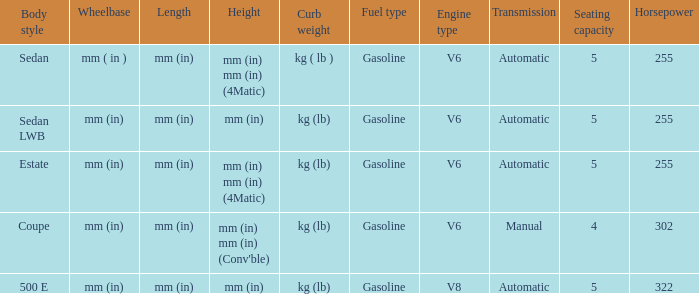Could you help me parse every detail presented in this table? {'header': ['Body style', 'Wheelbase', 'Length', 'Height', 'Curb weight', 'Fuel type', 'Engine type', 'Transmission', 'Seating capacity', 'Horsepower'], 'rows': [['Sedan', 'mm ( in )', 'mm (in)', 'mm (in) mm (in) (4Matic)', 'kg ( lb )', 'Gasoline', 'V6', 'Automatic', '5', '255'], ['Sedan LWB', 'mm (in)', 'mm (in)', 'mm (in)', 'kg (lb)', 'Gasoline', 'V6', 'Automatic', '5', '255'], ['Estate', 'mm (in)', 'mm (in)', 'mm (in) mm (in) (4Matic)', 'kg (lb)', 'Gasoline', 'V6', 'Automatic', '5', '255'], ['Coupe', 'mm (in)', 'mm (in)', "mm (in) mm (in) (Conv'ble)", 'kg (lb)', 'Gasoline', 'V6', 'Manual', '4', '302'], ['500 E', 'mm (in)', 'mm (in)', 'mm (in)', 'kg (lb)', 'Gasoline', 'V8', 'Automatic', '5', '322']]} What's the curb weight of the model with a wheelbase of mm (in) and height of mm (in) mm (in) (4Matic)? Kg ( lb ), kg (lb). 